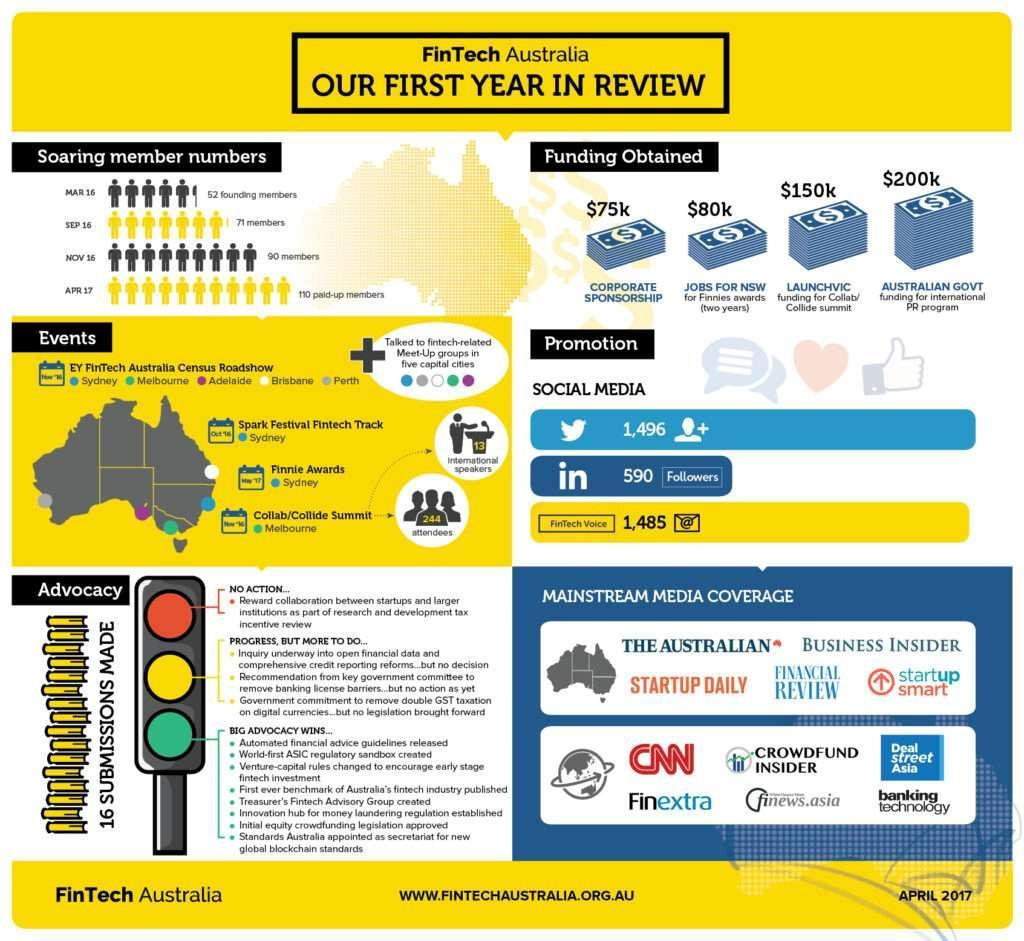what was the increase in members from Sep 16 to Nov 16
Answer the question with a short phrase. 19 Which colour denotes progress, but more to do, red or yellow? yellow How much was the funding for Finnies awards $80K How many messages through Fintech Voice 1,485 How many international speakers were there? 13 Where was the Finnie Awards conducted Sydney how many followers in twitter 1496 how many attendees were there 244 from where was the least funding obtained corporate sponsorship 